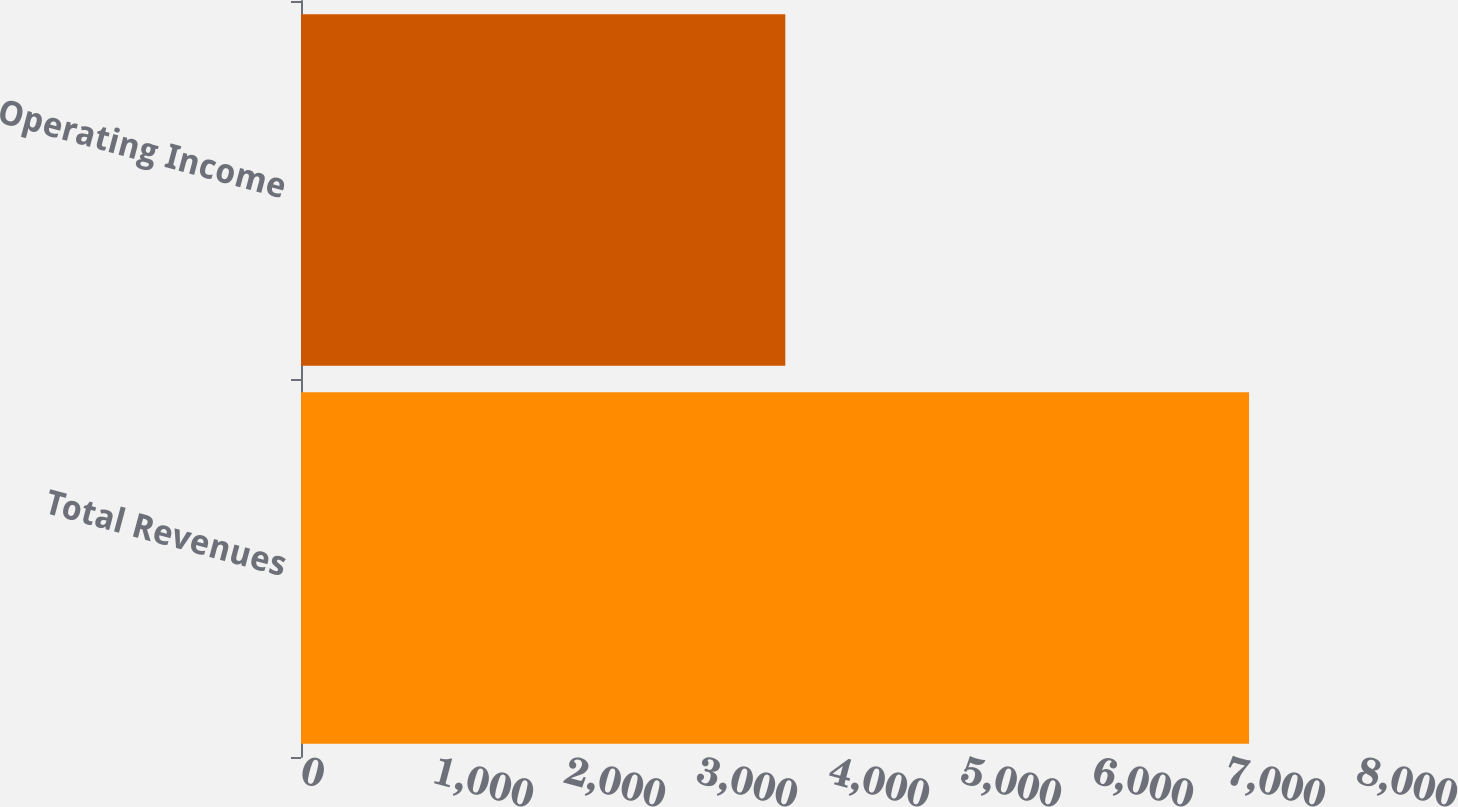Convert chart to OTSL. <chart><loc_0><loc_0><loc_500><loc_500><bar_chart><fcel>Total Revenues<fcel>Operating Income<nl><fcel>7182<fcel>3669<nl></chart> 